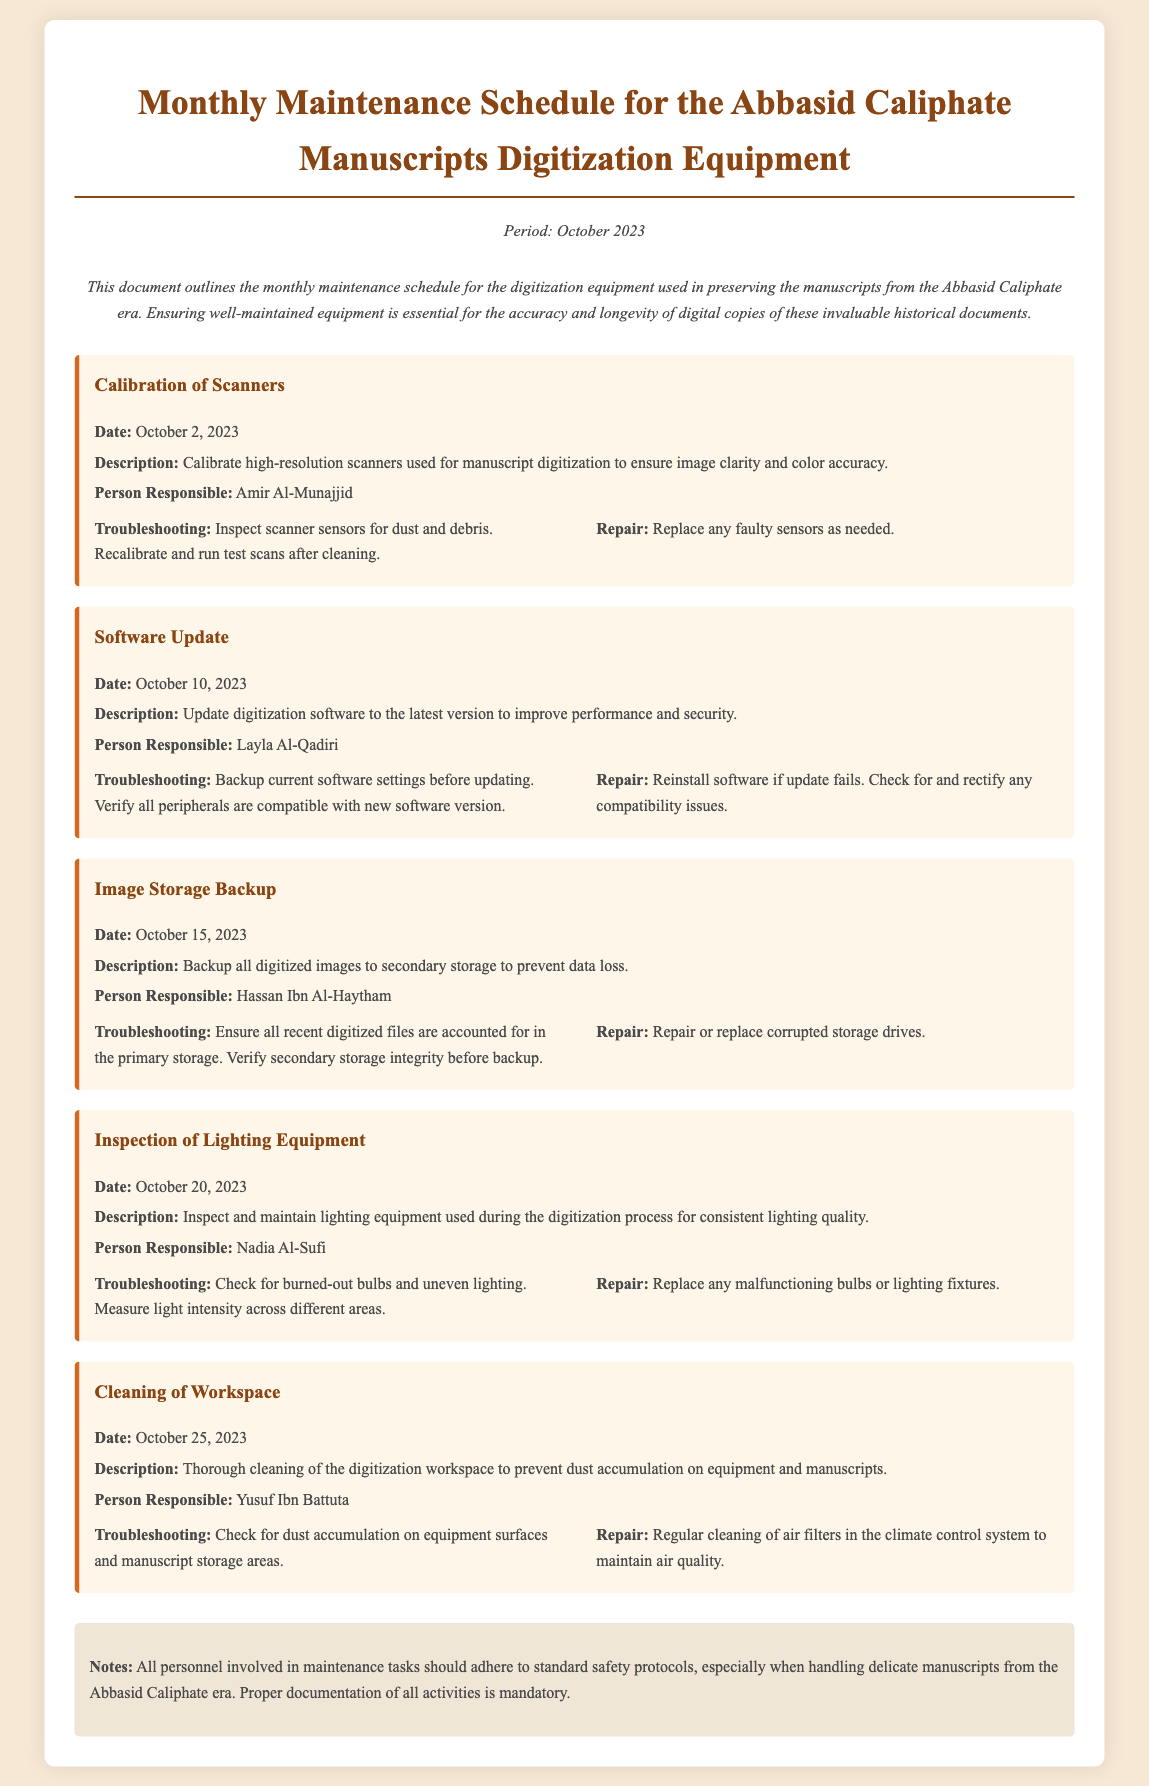What is the title of the document? The title of the document is given at the top, which provides information about its contents.
Answer: Monthly Maintenance Schedule for the Abbasid Caliphate Manuscripts Digitization Equipment Who is responsible for the calibration of scanners? The document specifies the person responsible for the calibration task listed in the maintenance log.
Answer: Amir Al-Munajjid When is the software update scheduled? The date for the software update is directly indicated in the maintenance schedule as part of the task descriptions.
Answer: October 10, 2023 What needs to be ensured before backing up the images? The troubleshooting section for image storage backup specifies what needs to be done before the backup process.
Answer: Verify secondary storage integrity How many tasks are listed in the document? The document outlines a total number of maintenance tasks related to the digitization equipment.
Answer: Five What is one of the repair activities mentioned for lighting equipment? The document includes repair actions that address issues found during the inspection of lighting equipment.
Answer: Replace any malfunctioning bulbs or lighting fixtures What should all personnel adhere to during maintenance tasks? There is a note at the end of the document that emphasizes a specific requirement for all personnel.
Answer: Standard safety protocols Who is responsible for the cleaning of the workspace? The document states the name of the person assigned to maintain a clean workspace in the digitization area.
Answer: Yusuf Ibn Battuta What is the purpose of the maintenance log? The introductory paragraph of the document explains the main objective of maintaining a regular maintenance schedule.
Answer: To ensure well-maintained equipment for the accuracy and longevity of digital copies 